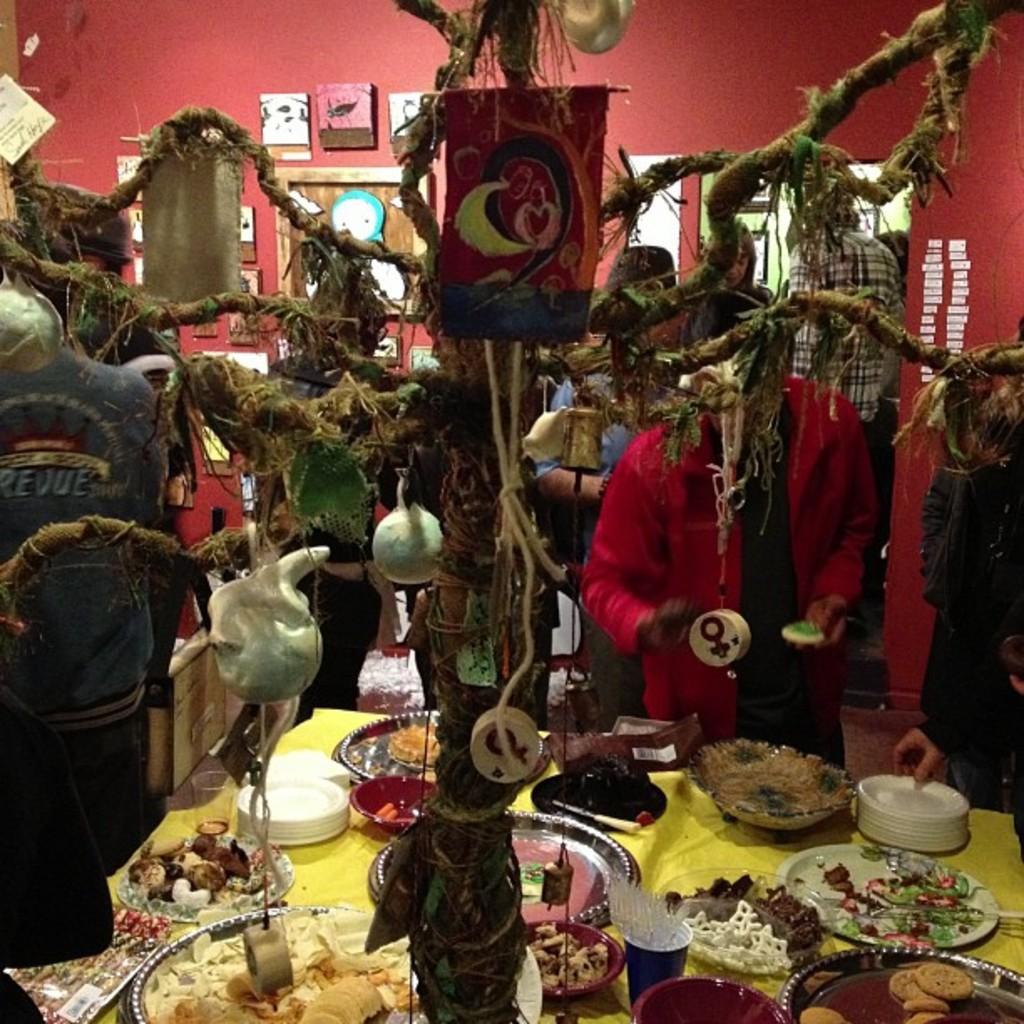Describe this image in one or two sentences. In this image there is an art in the middle. At the bottom there is a table on which there are plates,bowls,glasses on it. In the plate there is some food stuff. In the middle there is a tree to which there is a flag and balls. In the background there are few people standing on the ground. There are pictures attached to the wall. 